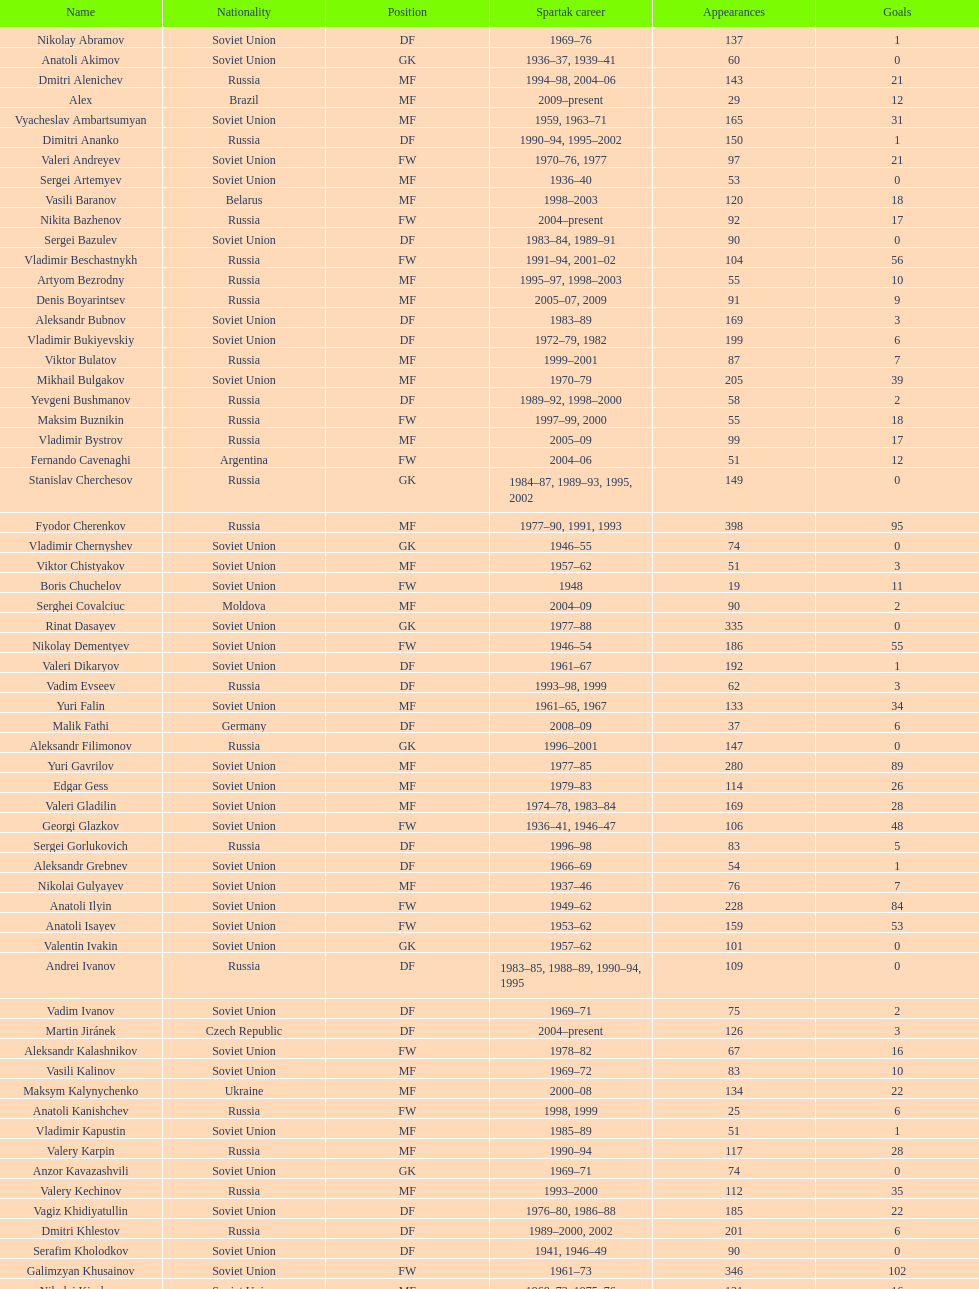How many players had at least 20 league goals scored? 56. 